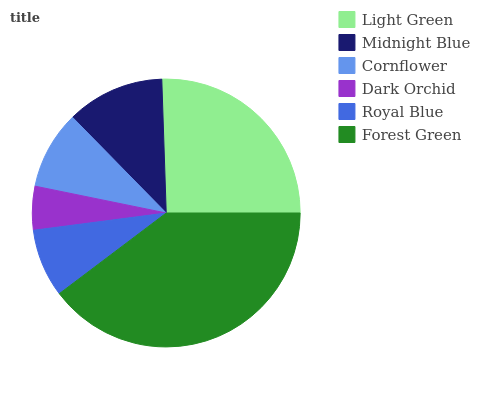Is Dark Orchid the minimum?
Answer yes or no. Yes. Is Forest Green the maximum?
Answer yes or no. Yes. Is Midnight Blue the minimum?
Answer yes or no. No. Is Midnight Blue the maximum?
Answer yes or no. No. Is Light Green greater than Midnight Blue?
Answer yes or no. Yes. Is Midnight Blue less than Light Green?
Answer yes or no. Yes. Is Midnight Blue greater than Light Green?
Answer yes or no. No. Is Light Green less than Midnight Blue?
Answer yes or no. No. Is Midnight Blue the high median?
Answer yes or no. Yes. Is Cornflower the low median?
Answer yes or no. Yes. Is Dark Orchid the high median?
Answer yes or no. No. Is Forest Green the low median?
Answer yes or no. No. 